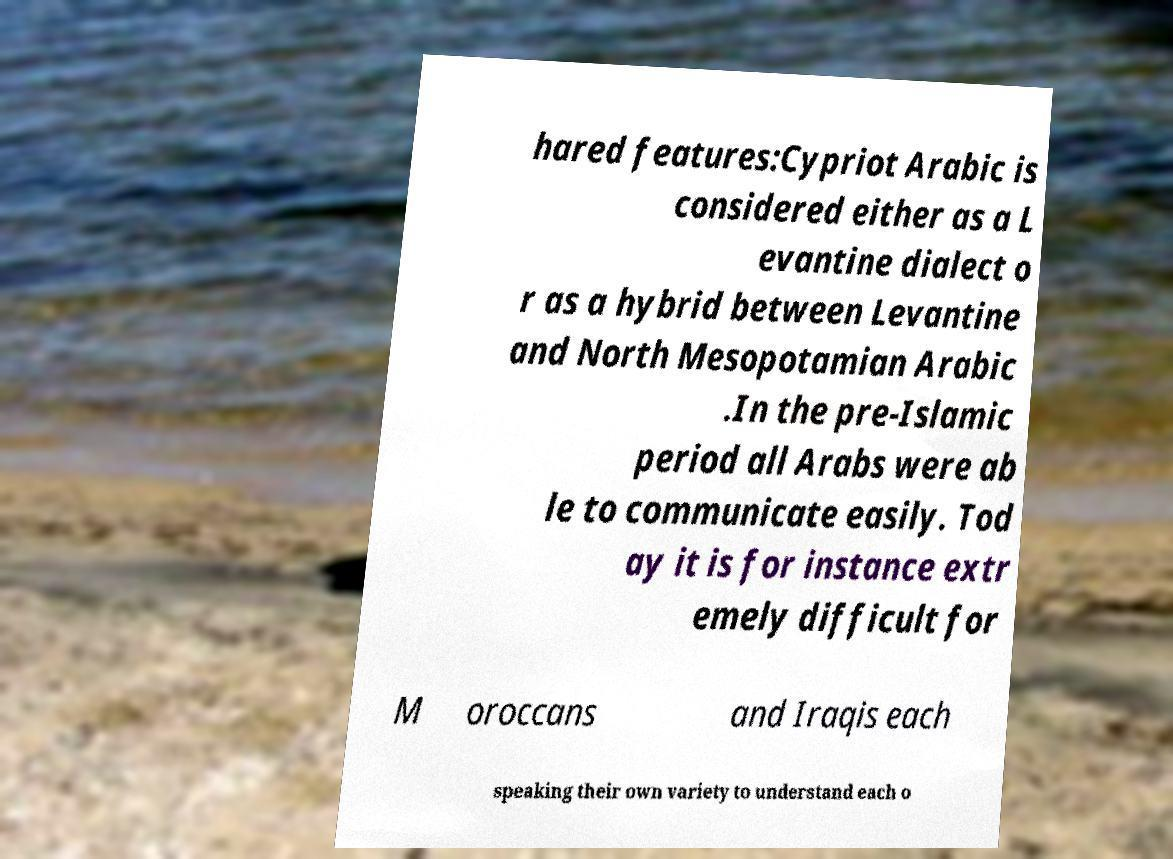Please identify and transcribe the text found in this image. hared features:Cypriot Arabic is considered either as a L evantine dialect o r as a hybrid between Levantine and North Mesopotamian Arabic .In the pre-Islamic period all Arabs were ab le to communicate easily. Tod ay it is for instance extr emely difficult for M oroccans and Iraqis each speaking their own variety to understand each o 